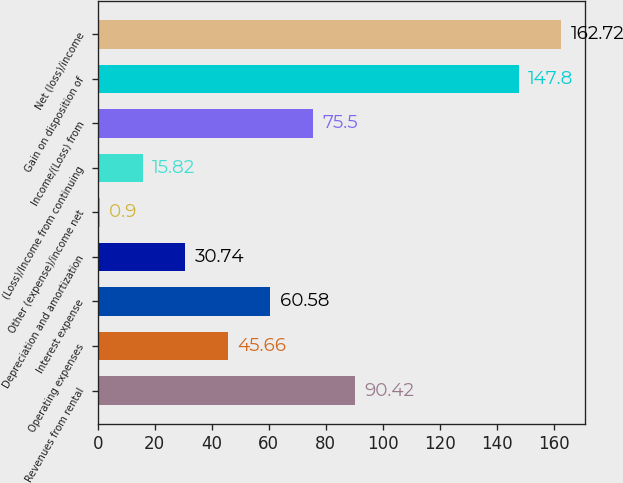Convert chart. <chart><loc_0><loc_0><loc_500><loc_500><bar_chart><fcel>Revenues from rental<fcel>Operating expenses<fcel>Interest expense<fcel>Depreciation and amortization<fcel>Other (expense)/income net<fcel>(Loss)/Income from continuing<fcel>Income/(Loss) from<fcel>Gain on disposition of<fcel>Net (loss)/income<nl><fcel>90.42<fcel>45.66<fcel>60.58<fcel>30.74<fcel>0.9<fcel>15.82<fcel>75.5<fcel>147.8<fcel>162.72<nl></chart> 